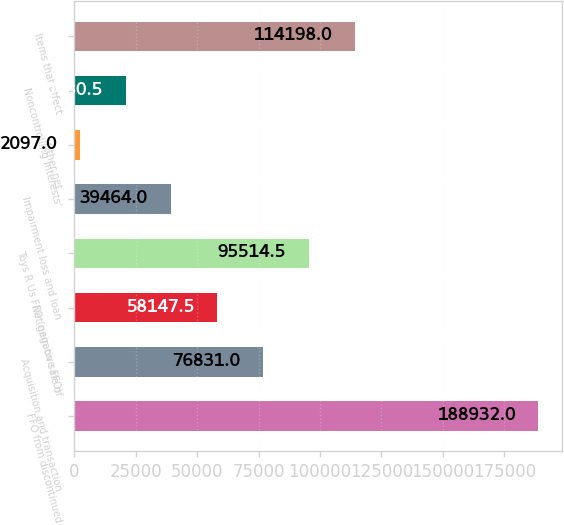Convert chart to OTSL. <chart><loc_0><loc_0><loc_500><loc_500><bar_chart><fcel>FFO from discontinued<fcel>Acquisition and transaction<fcel>Net gain on sale of<fcel>Toys R Us FFO (negative FFO)<fcel>Impairment loss and loan<fcel>Other net<fcel>Noncontrolling interests'<fcel>Items that affect<nl><fcel>188932<fcel>76831<fcel>58147.5<fcel>95514.5<fcel>39464<fcel>2097<fcel>20780.5<fcel>114198<nl></chart> 